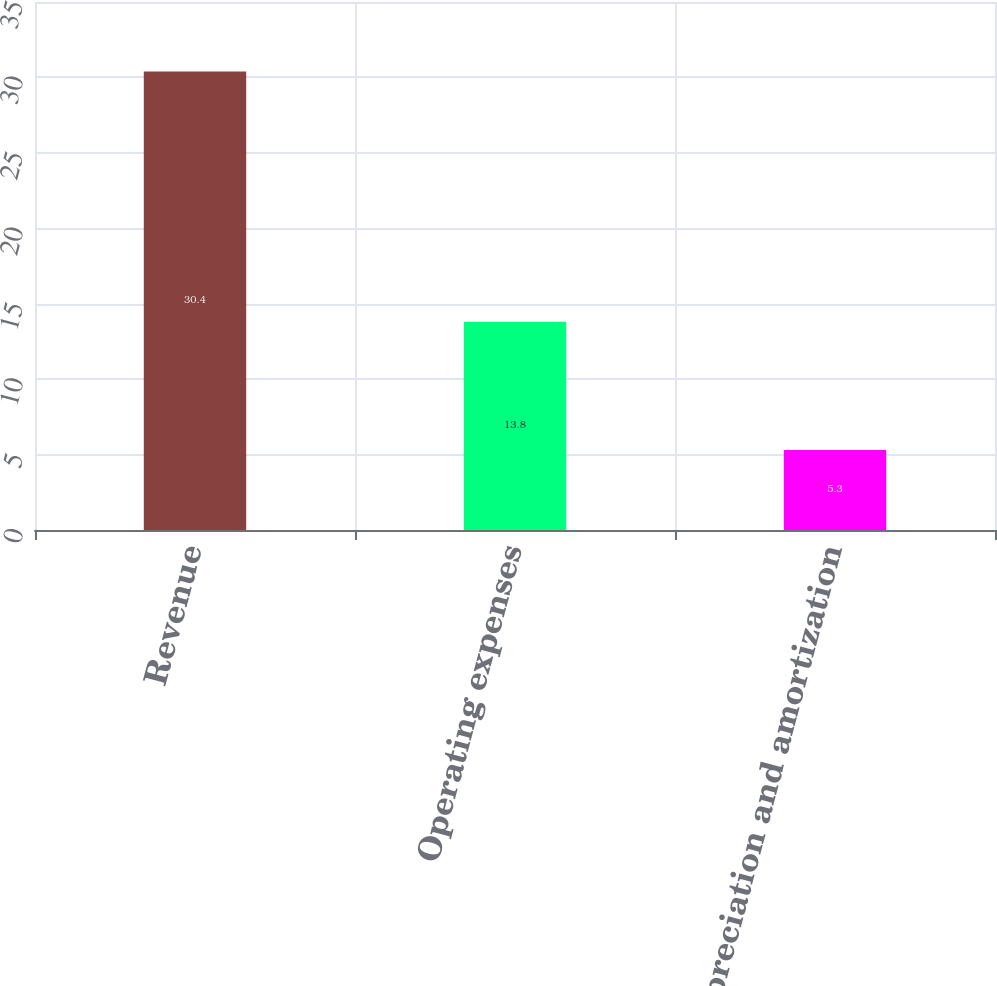Convert chart. <chart><loc_0><loc_0><loc_500><loc_500><bar_chart><fcel>Revenue<fcel>Operating expenses<fcel>Depreciation and amortization<nl><fcel>30.4<fcel>13.8<fcel>5.3<nl></chart> 